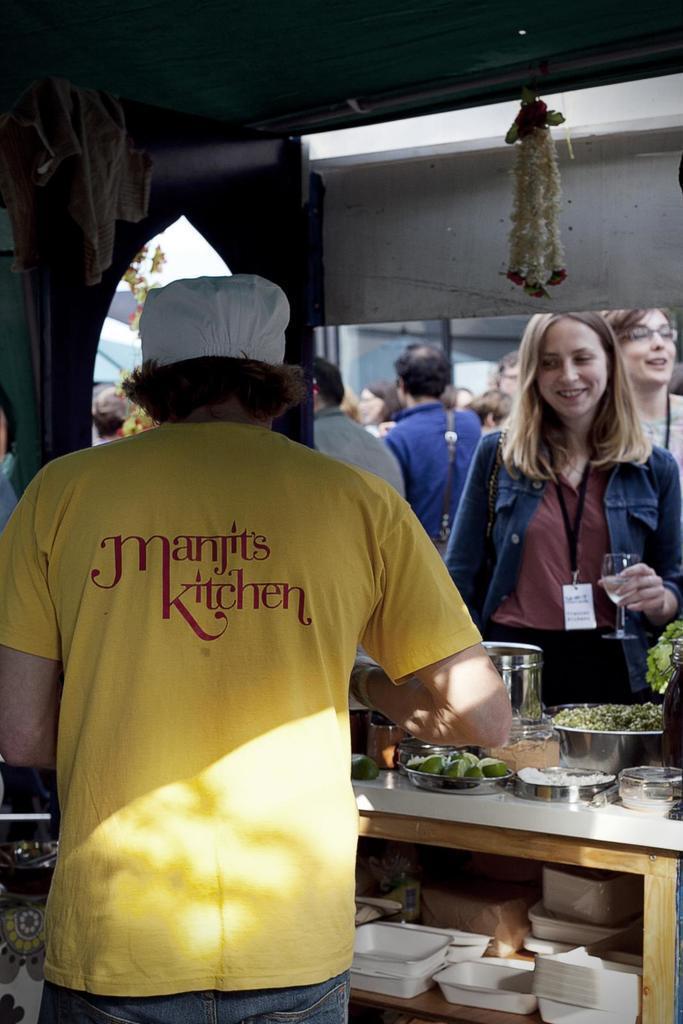Describe this image in one or two sentences. In the picture we can see a man standing near the table and the man is wearing a yellow T-shirt, with a white cap and to the opposite we can see a woman standing with a tag and ID card and on the table we can see some food items in the bowls. 